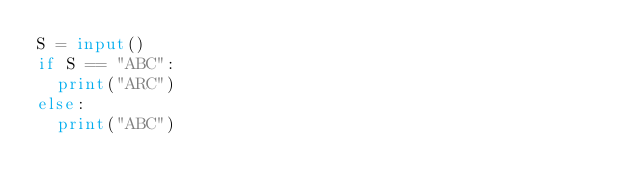<code> <loc_0><loc_0><loc_500><loc_500><_Python_>S = input()
if S == "ABC":
  print("ARC")
else:
  print("ABC")</code> 